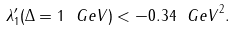Convert formula to latex. <formula><loc_0><loc_0><loc_500><loc_500>\lambda ^ { \prime } _ { 1 } ( \Delta = 1 { \mathrm \ G e V } ) < - 0 . 3 4 { \mathrm \ G e V } ^ { 2 } .</formula> 